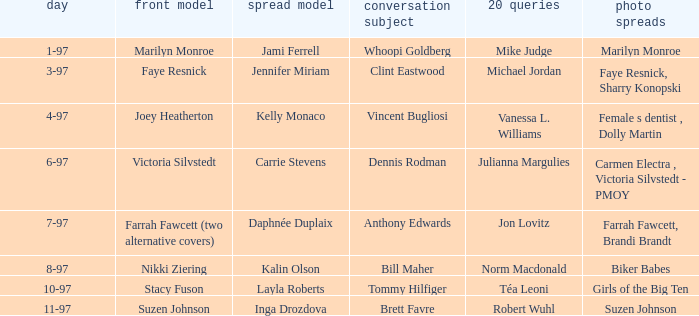Who was the interview subject on the date 1-97? Whoopi Goldberg. 